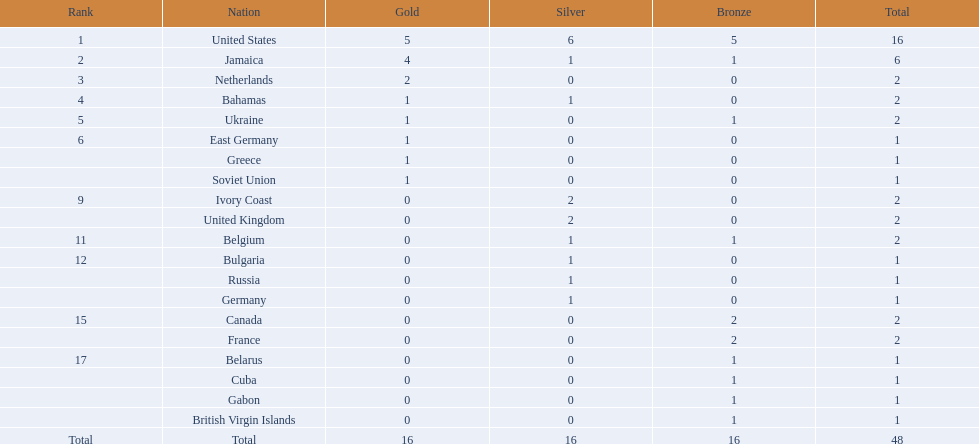What was the maximum number of medals received by any country? 16. Which country was awarded that many medals? United States. 